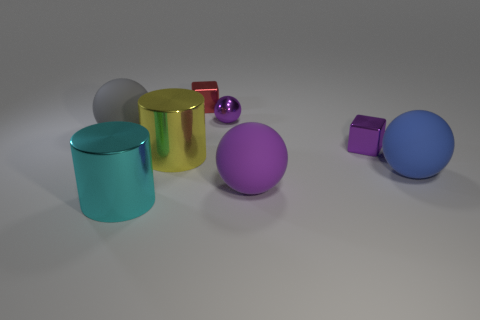Focusing on the two cylindrical objects, what are their distinct features besides their color? The two cylindrical objects differ in their finishes and reflectiveness. The one on the left is matte grey and has a rougher texture that doesn't reflect the environment. In contrast, the one on the right is shiny gold, has a smooth surface, and reflects its surroundings with a clear, mirror-like quality. 